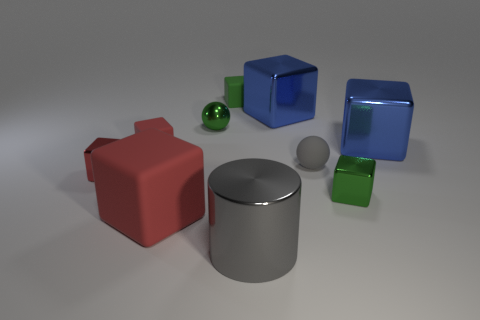Subtract all green rubber cubes. How many cubes are left? 6 Subtract all green spheres. How many spheres are left? 1 Subtract all blue spheres. How many blue blocks are left? 2 Add 3 blue things. How many blue things are left? 5 Add 1 big green cylinders. How many big green cylinders exist? 1 Subtract 1 gray balls. How many objects are left? 9 Subtract all balls. How many objects are left? 8 Subtract 1 spheres. How many spheres are left? 1 Subtract all red cubes. Subtract all purple spheres. How many cubes are left? 4 Subtract all tiny green shiny blocks. Subtract all small green matte cylinders. How many objects are left? 9 